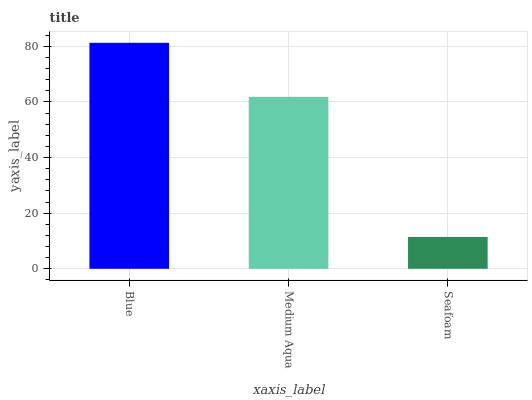Is Seafoam the minimum?
Answer yes or no. Yes. Is Blue the maximum?
Answer yes or no. Yes. Is Medium Aqua the minimum?
Answer yes or no. No. Is Medium Aqua the maximum?
Answer yes or no. No. Is Blue greater than Medium Aqua?
Answer yes or no. Yes. Is Medium Aqua less than Blue?
Answer yes or no. Yes. Is Medium Aqua greater than Blue?
Answer yes or no. No. Is Blue less than Medium Aqua?
Answer yes or no. No. Is Medium Aqua the high median?
Answer yes or no. Yes. Is Medium Aqua the low median?
Answer yes or no. Yes. Is Seafoam the high median?
Answer yes or no. No. Is Blue the low median?
Answer yes or no. No. 